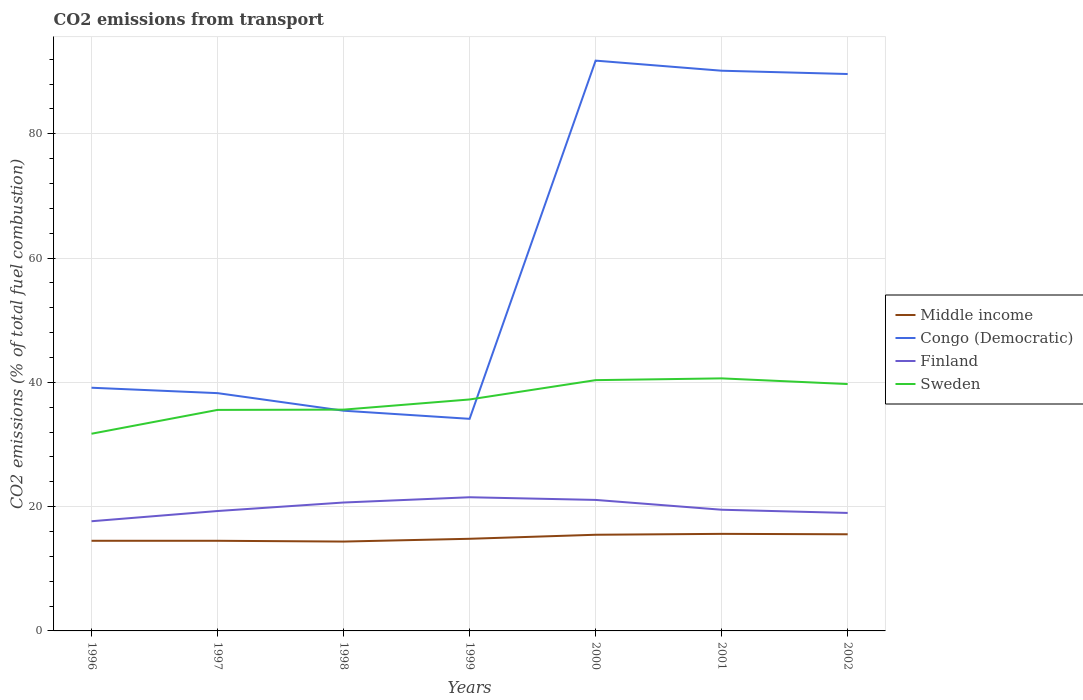Does the line corresponding to Sweden intersect with the line corresponding to Middle income?
Keep it short and to the point. No. Across all years, what is the maximum total CO2 emitted in Sweden?
Keep it short and to the point. 31.73. In which year was the total CO2 emitted in Middle income maximum?
Provide a short and direct response. 1998. What is the total total CO2 emitted in Middle income in the graph?
Ensure brevity in your answer.  -1.04. What is the difference between the highest and the second highest total CO2 emitted in Congo (Democratic)?
Your answer should be compact. 57.64. Is the total CO2 emitted in Finland strictly greater than the total CO2 emitted in Middle income over the years?
Keep it short and to the point. No. How many lines are there?
Your answer should be compact. 4. How many years are there in the graph?
Provide a short and direct response. 7. What is the difference between two consecutive major ticks on the Y-axis?
Offer a terse response. 20. Does the graph contain grids?
Ensure brevity in your answer.  Yes. Where does the legend appear in the graph?
Ensure brevity in your answer.  Center right. How are the legend labels stacked?
Your response must be concise. Vertical. What is the title of the graph?
Offer a terse response. CO2 emissions from transport. What is the label or title of the X-axis?
Give a very brief answer. Years. What is the label or title of the Y-axis?
Offer a very short reply. CO2 emissions (% of total fuel combustion). What is the CO2 emissions (% of total fuel combustion) of Middle income in 1996?
Make the answer very short. 14.51. What is the CO2 emissions (% of total fuel combustion) in Congo (Democratic) in 1996?
Ensure brevity in your answer.  39.13. What is the CO2 emissions (% of total fuel combustion) of Finland in 1996?
Provide a short and direct response. 17.65. What is the CO2 emissions (% of total fuel combustion) in Sweden in 1996?
Give a very brief answer. 31.73. What is the CO2 emissions (% of total fuel combustion) in Middle income in 1997?
Your answer should be very brief. 14.5. What is the CO2 emissions (% of total fuel combustion) in Congo (Democratic) in 1997?
Offer a very short reply. 38.26. What is the CO2 emissions (% of total fuel combustion) of Finland in 1997?
Offer a very short reply. 19.29. What is the CO2 emissions (% of total fuel combustion) of Sweden in 1997?
Your response must be concise. 35.56. What is the CO2 emissions (% of total fuel combustion) of Middle income in 1998?
Your response must be concise. 14.38. What is the CO2 emissions (% of total fuel combustion) in Congo (Democratic) in 1998?
Your answer should be very brief. 35.43. What is the CO2 emissions (% of total fuel combustion) in Finland in 1998?
Provide a succinct answer. 20.66. What is the CO2 emissions (% of total fuel combustion) of Sweden in 1998?
Make the answer very short. 35.61. What is the CO2 emissions (% of total fuel combustion) of Middle income in 1999?
Offer a terse response. 14.83. What is the CO2 emissions (% of total fuel combustion) in Congo (Democratic) in 1999?
Give a very brief answer. 34.13. What is the CO2 emissions (% of total fuel combustion) of Finland in 1999?
Your answer should be very brief. 21.51. What is the CO2 emissions (% of total fuel combustion) in Sweden in 1999?
Offer a very short reply. 37.24. What is the CO2 emissions (% of total fuel combustion) of Middle income in 2000?
Your response must be concise. 15.47. What is the CO2 emissions (% of total fuel combustion) of Congo (Democratic) in 2000?
Your answer should be very brief. 91.76. What is the CO2 emissions (% of total fuel combustion) in Finland in 2000?
Your answer should be compact. 21.08. What is the CO2 emissions (% of total fuel combustion) of Sweden in 2000?
Ensure brevity in your answer.  40.35. What is the CO2 emissions (% of total fuel combustion) of Middle income in 2001?
Offer a terse response. 15.62. What is the CO2 emissions (% of total fuel combustion) of Congo (Democratic) in 2001?
Your response must be concise. 90.14. What is the CO2 emissions (% of total fuel combustion) in Finland in 2001?
Your response must be concise. 19.5. What is the CO2 emissions (% of total fuel combustion) of Sweden in 2001?
Your response must be concise. 40.64. What is the CO2 emissions (% of total fuel combustion) of Middle income in 2002?
Your response must be concise. 15.55. What is the CO2 emissions (% of total fuel combustion) in Congo (Democratic) in 2002?
Give a very brief answer. 89.61. What is the CO2 emissions (% of total fuel combustion) in Finland in 2002?
Make the answer very short. 18.98. What is the CO2 emissions (% of total fuel combustion) in Sweden in 2002?
Provide a succinct answer. 39.72. Across all years, what is the maximum CO2 emissions (% of total fuel combustion) of Middle income?
Offer a very short reply. 15.62. Across all years, what is the maximum CO2 emissions (% of total fuel combustion) in Congo (Democratic)?
Make the answer very short. 91.76. Across all years, what is the maximum CO2 emissions (% of total fuel combustion) in Finland?
Make the answer very short. 21.51. Across all years, what is the maximum CO2 emissions (% of total fuel combustion) of Sweden?
Your answer should be very brief. 40.64. Across all years, what is the minimum CO2 emissions (% of total fuel combustion) of Middle income?
Your answer should be compact. 14.38. Across all years, what is the minimum CO2 emissions (% of total fuel combustion) of Congo (Democratic)?
Your response must be concise. 34.13. Across all years, what is the minimum CO2 emissions (% of total fuel combustion) of Finland?
Your response must be concise. 17.65. Across all years, what is the minimum CO2 emissions (% of total fuel combustion) in Sweden?
Provide a succinct answer. 31.73. What is the total CO2 emissions (% of total fuel combustion) of Middle income in the graph?
Make the answer very short. 104.85. What is the total CO2 emissions (% of total fuel combustion) of Congo (Democratic) in the graph?
Offer a very short reply. 418.47. What is the total CO2 emissions (% of total fuel combustion) in Finland in the graph?
Provide a succinct answer. 138.68. What is the total CO2 emissions (% of total fuel combustion) of Sweden in the graph?
Ensure brevity in your answer.  260.85. What is the difference between the CO2 emissions (% of total fuel combustion) of Middle income in 1996 and that in 1997?
Ensure brevity in your answer.  0. What is the difference between the CO2 emissions (% of total fuel combustion) of Congo (Democratic) in 1996 and that in 1997?
Ensure brevity in your answer.  0.87. What is the difference between the CO2 emissions (% of total fuel combustion) in Finland in 1996 and that in 1997?
Keep it short and to the point. -1.65. What is the difference between the CO2 emissions (% of total fuel combustion) in Sweden in 1996 and that in 1997?
Offer a very short reply. -3.83. What is the difference between the CO2 emissions (% of total fuel combustion) in Middle income in 1996 and that in 1998?
Your answer should be very brief. 0.13. What is the difference between the CO2 emissions (% of total fuel combustion) in Congo (Democratic) in 1996 and that in 1998?
Provide a succinct answer. 3.7. What is the difference between the CO2 emissions (% of total fuel combustion) of Finland in 1996 and that in 1998?
Keep it short and to the point. -3.01. What is the difference between the CO2 emissions (% of total fuel combustion) in Sweden in 1996 and that in 1998?
Provide a short and direct response. -3.88. What is the difference between the CO2 emissions (% of total fuel combustion) in Middle income in 1996 and that in 1999?
Ensure brevity in your answer.  -0.32. What is the difference between the CO2 emissions (% of total fuel combustion) in Congo (Democratic) in 1996 and that in 1999?
Your response must be concise. 5. What is the difference between the CO2 emissions (% of total fuel combustion) of Finland in 1996 and that in 1999?
Ensure brevity in your answer.  -3.86. What is the difference between the CO2 emissions (% of total fuel combustion) of Sweden in 1996 and that in 1999?
Your answer should be compact. -5.51. What is the difference between the CO2 emissions (% of total fuel combustion) in Middle income in 1996 and that in 2000?
Offer a terse response. -0.97. What is the difference between the CO2 emissions (% of total fuel combustion) in Congo (Democratic) in 1996 and that in 2000?
Provide a succinct answer. -52.63. What is the difference between the CO2 emissions (% of total fuel combustion) in Finland in 1996 and that in 2000?
Your answer should be very brief. -3.43. What is the difference between the CO2 emissions (% of total fuel combustion) of Sweden in 1996 and that in 2000?
Provide a short and direct response. -8.62. What is the difference between the CO2 emissions (% of total fuel combustion) in Middle income in 1996 and that in 2001?
Provide a succinct answer. -1.11. What is the difference between the CO2 emissions (% of total fuel combustion) in Congo (Democratic) in 1996 and that in 2001?
Keep it short and to the point. -51.01. What is the difference between the CO2 emissions (% of total fuel combustion) in Finland in 1996 and that in 2001?
Ensure brevity in your answer.  -1.85. What is the difference between the CO2 emissions (% of total fuel combustion) in Sweden in 1996 and that in 2001?
Provide a short and direct response. -8.91. What is the difference between the CO2 emissions (% of total fuel combustion) of Middle income in 1996 and that in 2002?
Offer a very short reply. -1.04. What is the difference between the CO2 emissions (% of total fuel combustion) of Congo (Democratic) in 1996 and that in 2002?
Offer a very short reply. -50.48. What is the difference between the CO2 emissions (% of total fuel combustion) of Finland in 1996 and that in 2002?
Offer a very short reply. -1.34. What is the difference between the CO2 emissions (% of total fuel combustion) in Sweden in 1996 and that in 2002?
Provide a succinct answer. -7.99. What is the difference between the CO2 emissions (% of total fuel combustion) of Middle income in 1997 and that in 1998?
Your answer should be very brief. 0.13. What is the difference between the CO2 emissions (% of total fuel combustion) of Congo (Democratic) in 1997 and that in 1998?
Keep it short and to the point. 2.83. What is the difference between the CO2 emissions (% of total fuel combustion) in Finland in 1997 and that in 1998?
Provide a short and direct response. -1.37. What is the difference between the CO2 emissions (% of total fuel combustion) of Sweden in 1997 and that in 1998?
Your response must be concise. -0.05. What is the difference between the CO2 emissions (% of total fuel combustion) in Middle income in 1997 and that in 1999?
Give a very brief answer. -0.32. What is the difference between the CO2 emissions (% of total fuel combustion) in Congo (Democratic) in 1997 and that in 1999?
Offer a terse response. 4.13. What is the difference between the CO2 emissions (% of total fuel combustion) in Finland in 1997 and that in 1999?
Ensure brevity in your answer.  -2.22. What is the difference between the CO2 emissions (% of total fuel combustion) of Sweden in 1997 and that in 1999?
Your response must be concise. -1.68. What is the difference between the CO2 emissions (% of total fuel combustion) in Middle income in 1997 and that in 2000?
Ensure brevity in your answer.  -0.97. What is the difference between the CO2 emissions (% of total fuel combustion) of Congo (Democratic) in 1997 and that in 2000?
Offer a terse response. -53.5. What is the difference between the CO2 emissions (% of total fuel combustion) in Finland in 1997 and that in 2000?
Your answer should be compact. -1.79. What is the difference between the CO2 emissions (% of total fuel combustion) in Sweden in 1997 and that in 2000?
Your answer should be very brief. -4.79. What is the difference between the CO2 emissions (% of total fuel combustion) in Middle income in 1997 and that in 2001?
Your answer should be very brief. -1.11. What is the difference between the CO2 emissions (% of total fuel combustion) in Congo (Democratic) in 1997 and that in 2001?
Offer a terse response. -51.88. What is the difference between the CO2 emissions (% of total fuel combustion) in Finland in 1997 and that in 2001?
Keep it short and to the point. -0.21. What is the difference between the CO2 emissions (% of total fuel combustion) in Sweden in 1997 and that in 2001?
Make the answer very short. -5.07. What is the difference between the CO2 emissions (% of total fuel combustion) in Middle income in 1997 and that in 2002?
Offer a terse response. -1.04. What is the difference between the CO2 emissions (% of total fuel combustion) in Congo (Democratic) in 1997 and that in 2002?
Offer a terse response. -51.35. What is the difference between the CO2 emissions (% of total fuel combustion) of Finland in 1997 and that in 2002?
Your answer should be compact. 0.31. What is the difference between the CO2 emissions (% of total fuel combustion) of Sweden in 1997 and that in 2002?
Your answer should be compact. -4.16. What is the difference between the CO2 emissions (% of total fuel combustion) in Middle income in 1998 and that in 1999?
Your answer should be compact. -0.45. What is the difference between the CO2 emissions (% of total fuel combustion) of Congo (Democratic) in 1998 and that in 1999?
Offer a very short reply. 1.31. What is the difference between the CO2 emissions (% of total fuel combustion) of Finland in 1998 and that in 1999?
Keep it short and to the point. -0.85. What is the difference between the CO2 emissions (% of total fuel combustion) of Sweden in 1998 and that in 1999?
Provide a succinct answer. -1.64. What is the difference between the CO2 emissions (% of total fuel combustion) in Middle income in 1998 and that in 2000?
Provide a succinct answer. -1.1. What is the difference between the CO2 emissions (% of total fuel combustion) in Congo (Democratic) in 1998 and that in 2000?
Provide a succinct answer. -56.33. What is the difference between the CO2 emissions (% of total fuel combustion) of Finland in 1998 and that in 2000?
Offer a very short reply. -0.42. What is the difference between the CO2 emissions (% of total fuel combustion) of Sweden in 1998 and that in 2000?
Provide a short and direct response. -4.75. What is the difference between the CO2 emissions (% of total fuel combustion) in Middle income in 1998 and that in 2001?
Provide a succinct answer. -1.24. What is the difference between the CO2 emissions (% of total fuel combustion) of Congo (Democratic) in 1998 and that in 2001?
Provide a short and direct response. -54.71. What is the difference between the CO2 emissions (% of total fuel combustion) in Finland in 1998 and that in 2001?
Provide a succinct answer. 1.16. What is the difference between the CO2 emissions (% of total fuel combustion) of Sweden in 1998 and that in 2001?
Offer a very short reply. -5.03. What is the difference between the CO2 emissions (% of total fuel combustion) in Middle income in 1998 and that in 2002?
Give a very brief answer. -1.17. What is the difference between the CO2 emissions (% of total fuel combustion) of Congo (Democratic) in 1998 and that in 2002?
Your answer should be compact. -54.18. What is the difference between the CO2 emissions (% of total fuel combustion) in Finland in 1998 and that in 2002?
Give a very brief answer. 1.68. What is the difference between the CO2 emissions (% of total fuel combustion) of Sweden in 1998 and that in 2002?
Offer a very short reply. -4.12. What is the difference between the CO2 emissions (% of total fuel combustion) in Middle income in 1999 and that in 2000?
Your answer should be compact. -0.65. What is the difference between the CO2 emissions (% of total fuel combustion) of Congo (Democratic) in 1999 and that in 2000?
Your answer should be compact. -57.64. What is the difference between the CO2 emissions (% of total fuel combustion) in Finland in 1999 and that in 2000?
Provide a succinct answer. 0.43. What is the difference between the CO2 emissions (% of total fuel combustion) in Sweden in 1999 and that in 2000?
Keep it short and to the point. -3.11. What is the difference between the CO2 emissions (% of total fuel combustion) of Middle income in 1999 and that in 2001?
Your answer should be compact. -0.79. What is the difference between the CO2 emissions (% of total fuel combustion) of Congo (Democratic) in 1999 and that in 2001?
Your answer should be very brief. -56.01. What is the difference between the CO2 emissions (% of total fuel combustion) of Finland in 1999 and that in 2001?
Your answer should be very brief. 2.01. What is the difference between the CO2 emissions (% of total fuel combustion) of Sweden in 1999 and that in 2001?
Give a very brief answer. -3.39. What is the difference between the CO2 emissions (% of total fuel combustion) in Middle income in 1999 and that in 2002?
Provide a short and direct response. -0.72. What is the difference between the CO2 emissions (% of total fuel combustion) of Congo (Democratic) in 1999 and that in 2002?
Your answer should be compact. -55.48. What is the difference between the CO2 emissions (% of total fuel combustion) in Finland in 1999 and that in 2002?
Provide a short and direct response. 2.52. What is the difference between the CO2 emissions (% of total fuel combustion) in Sweden in 1999 and that in 2002?
Your response must be concise. -2.48. What is the difference between the CO2 emissions (% of total fuel combustion) of Middle income in 2000 and that in 2001?
Your answer should be compact. -0.14. What is the difference between the CO2 emissions (% of total fuel combustion) of Congo (Democratic) in 2000 and that in 2001?
Your answer should be very brief. 1.62. What is the difference between the CO2 emissions (% of total fuel combustion) in Finland in 2000 and that in 2001?
Make the answer very short. 1.58. What is the difference between the CO2 emissions (% of total fuel combustion) in Sweden in 2000 and that in 2001?
Your response must be concise. -0.28. What is the difference between the CO2 emissions (% of total fuel combustion) of Middle income in 2000 and that in 2002?
Offer a terse response. -0.07. What is the difference between the CO2 emissions (% of total fuel combustion) of Congo (Democratic) in 2000 and that in 2002?
Make the answer very short. 2.15. What is the difference between the CO2 emissions (% of total fuel combustion) in Finland in 2000 and that in 2002?
Provide a succinct answer. 2.1. What is the difference between the CO2 emissions (% of total fuel combustion) in Sweden in 2000 and that in 2002?
Offer a very short reply. 0.63. What is the difference between the CO2 emissions (% of total fuel combustion) of Middle income in 2001 and that in 2002?
Your answer should be very brief. 0.07. What is the difference between the CO2 emissions (% of total fuel combustion) of Congo (Democratic) in 2001 and that in 2002?
Make the answer very short. 0.53. What is the difference between the CO2 emissions (% of total fuel combustion) of Finland in 2001 and that in 2002?
Your response must be concise. 0.52. What is the difference between the CO2 emissions (% of total fuel combustion) of Sweden in 2001 and that in 2002?
Make the answer very short. 0.91. What is the difference between the CO2 emissions (% of total fuel combustion) in Middle income in 1996 and the CO2 emissions (% of total fuel combustion) in Congo (Democratic) in 1997?
Provide a short and direct response. -23.76. What is the difference between the CO2 emissions (% of total fuel combustion) of Middle income in 1996 and the CO2 emissions (% of total fuel combustion) of Finland in 1997?
Offer a terse response. -4.79. What is the difference between the CO2 emissions (% of total fuel combustion) in Middle income in 1996 and the CO2 emissions (% of total fuel combustion) in Sweden in 1997?
Your response must be concise. -21.06. What is the difference between the CO2 emissions (% of total fuel combustion) in Congo (Democratic) in 1996 and the CO2 emissions (% of total fuel combustion) in Finland in 1997?
Offer a very short reply. 19.84. What is the difference between the CO2 emissions (% of total fuel combustion) in Congo (Democratic) in 1996 and the CO2 emissions (% of total fuel combustion) in Sweden in 1997?
Provide a succinct answer. 3.57. What is the difference between the CO2 emissions (% of total fuel combustion) in Finland in 1996 and the CO2 emissions (% of total fuel combustion) in Sweden in 1997?
Keep it short and to the point. -17.91. What is the difference between the CO2 emissions (% of total fuel combustion) of Middle income in 1996 and the CO2 emissions (% of total fuel combustion) of Congo (Democratic) in 1998?
Keep it short and to the point. -20.93. What is the difference between the CO2 emissions (% of total fuel combustion) in Middle income in 1996 and the CO2 emissions (% of total fuel combustion) in Finland in 1998?
Offer a terse response. -6.16. What is the difference between the CO2 emissions (% of total fuel combustion) in Middle income in 1996 and the CO2 emissions (% of total fuel combustion) in Sweden in 1998?
Your answer should be compact. -21.1. What is the difference between the CO2 emissions (% of total fuel combustion) in Congo (Democratic) in 1996 and the CO2 emissions (% of total fuel combustion) in Finland in 1998?
Make the answer very short. 18.47. What is the difference between the CO2 emissions (% of total fuel combustion) of Congo (Democratic) in 1996 and the CO2 emissions (% of total fuel combustion) of Sweden in 1998?
Your answer should be compact. 3.52. What is the difference between the CO2 emissions (% of total fuel combustion) in Finland in 1996 and the CO2 emissions (% of total fuel combustion) in Sweden in 1998?
Your answer should be compact. -17.96. What is the difference between the CO2 emissions (% of total fuel combustion) of Middle income in 1996 and the CO2 emissions (% of total fuel combustion) of Congo (Democratic) in 1999?
Your response must be concise. -19.62. What is the difference between the CO2 emissions (% of total fuel combustion) in Middle income in 1996 and the CO2 emissions (% of total fuel combustion) in Finland in 1999?
Provide a succinct answer. -7. What is the difference between the CO2 emissions (% of total fuel combustion) in Middle income in 1996 and the CO2 emissions (% of total fuel combustion) in Sweden in 1999?
Your response must be concise. -22.74. What is the difference between the CO2 emissions (% of total fuel combustion) of Congo (Democratic) in 1996 and the CO2 emissions (% of total fuel combustion) of Finland in 1999?
Your answer should be compact. 17.62. What is the difference between the CO2 emissions (% of total fuel combustion) of Congo (Democratic) in 1996 and the CO2 emissions (% of total fuel combustion) of Sweden in 1999?
Your response must be concise. 1.89. What is the difference between the CO2 emissions (% of total fuel combustion) in Finland in 1996 and the CO2 emissions (% of total fuel combustion) in Sweden in 1999?
Ensure brevity in your answer.  -19.59. What is the difference between the CO2 emissions (% of total fuel combustion) of Middle income in 1996 and the CO2 emissions (% of total fuel combustion) of Congo (Democratic) in 2000?
Your answer should be compact. -77.26. What is the difference between the CO2 emissions (% of total fuel combustion) of Middle income in 1996 and the CO2 emissions (% of total fuel combustion) of Finland in 2000?
Your response must be concise. -6.57. What is the difference between the CO2 emissions (% of total fuel combustion) in Middle income in 1996 and the CO2 emissions (% of total fuel combustion) in Sweden in 2000?
Your answer should be compact. -25.85. What is the difference between the CO2 emissions (% of total fuel combustion) of Congo (Democratic) in 1996 and the CO2 emissions (% of total fuel combustion) of Finland in 2000?
Provide a short and direct response. 18.05. What is the difference between the CO2 emissions (% of total fuel combustion) in Congo (Democratic) in 1996 and the CO2 emissions (% of total fuel combustion) in Sweden in 2000?
Give a very brief answer. -1.22. What is the difference between the CO2 emissions (% of total fuel combustion) in Finland in 1996 and the CO2 emissions (% of total fuel combustion) in Sweden in 2000?
Ensure brevity in your answer.  -22.7. What is the difference between the CO2 emissions (% of total fuel combustion) in Middle income in 1996 and the CO2 emissions (% of total fuel combustion) in Congo (Democratic) in 2001?
Ensure brevity in your answer.  -75.64. What is the difference between the CO2 emissions (% of total fuel combustion) of Middle income in 1996 and the CO2 emissions (% of total fuel combustion) of Finland in 2001?
Ensure brevity in your answer.  -4.99. What is the difference between the CO2 emissions (% of total fuel combustion) in Middle income in 1996 and the CO2 emissions (% of total fuel combustion) in Sweden in 2001?
Your response must be concise. -26.13. What is the difference between the CO2 emissions (% of total fuel combustion) of Congo (Democratic) in 1996 and the CO2 emissions (% of total fuel combustion) of Finland in 2001?
Provide a succinct answer. 19.63. What is the difference between the CO2 emissions (% of total fuel combustion) of Congo (Democratic) in 1996 and the CO2 emissions (% of total fuel combustion) of Sweden in 2001?
Your answer should be very brief. -1.51. What is the difference between the CO2 emissions (% of total fuel combustion) in Finland in 1996 and the CO2 emissions (% of total fuel combustion) in Sweden in 2001?
Your response must be concise. -22.99. What is the difference between the CO2 emissions (% of total fuel combustion) of Middle income in 1996 and the CO2 emissions (% of total fuel combustion) of Congo (Democratic) in 2002?
Your answer should be compact. -75.11. What is the difference between the CO2 emissions (% of total fuel combustion) in Middle income in 1996 and the CO2 emissions (% of total fuel combustion) in Finland in 2002?
Ensure brevity in your answer.  -4.48. What is the difference between the CO2 emissions (% of total fuel combustion) in Middle income in 1996 and the CO2 emissions (% of total fuel combustion) in Sweden in 2002?
Give a very brief answer. -25.22. What is the difference between the CO2 emissions (% of total fuel combustion) of Congo (Democratic) in 1996 and the CO2 emissions (% of total fuel combustion) of Finland in 2002?
Your answer should be very brief. 20.15. What is the difference between the CO2 emissions (% of total fuel combustion) of Congo (Democratic) in 1996 and the CO2 emissions (% of total fuel combustion) of Sweden in 2002?
Your answer should be compact. -0.59. What is the difference between the CO2 emissions (% of total fuel combustion) in Finland in 1996 and the CO2 emissions (% of total fuel combustion) in Sweden in 2002?
Give a very brief answer. -22.07. What is the difference between the CO2 emissions (% of total fuel combustion) in Middle income in 1997 and the CO2 emissions (% of total fuel combustion) in Congo (Democratic) in 1998?
Make the answer very short. -20.93. What is the difference between the CO2 emissions (% of total fuel combustion) of Middle income in 1997 and the CO2 emissions (% of total fuel combustion) of Finland in 1998?
Keep it short and to the point. -6.16. What is the difference between the CO2 emissions (% of total fuel combustion) in Middle income in 1997 and the CO2 emissions (% of total fuel combustion) in Sweden in 1998?
Keep it short and to the point. -21.1. What is the difference between the CO2 emissions (% of total fuel combustion) of Congo (Democratic) in 1997 and the CO2 emissions (% of total fuel combustion) of Finland in 1998?
Offer a terse response. 17.6. What is the difference between the CO2 emissions (% of total fuel combustion) of Congo (Democratic) in 1997 and the CO2 emissions (% of total fuel combustion) of Sweden in 1998?
Ensure brevity in your answer.  2.65. What is the difference between the CO2 emissions (% of total fuel combustion) of Finland in 1997 and the CO2 emissions (% of total fuel combustion) of Sweden in 1998?
Offer a very short reply. -16.31. What is the difference between the CO2 emissions (% of total fuel combustion) in Middle income in 1997 and the CO2 emissions (% of total fuel combustion) in Congo (Democratic) in 1999?
Provide a succinct answer. -19.62. What is the difference between the CO2 emissions (% of total fuel combustion) of Middle income in 1997 and the CO2 emissions (% of total fuel combustion) of Finland in 1999?
Your answer should be very brief. -7. What is the difference between the CO2 emissions (% of total fuel combustion) in Middle income in 1997 and the CO2 emissions (% of total fuel combustion) in Sweden in 1999?
Your answer should be very brief. -22.74. What is the difference between the CO2 emissions (% of total fuel combustion) of Congo (Democratic) in 1997 and the CO2 emissions (% of total fuel combustion) of Finland in 1999?
Make the answer very short. 16.75. What is the difference between the CO2 emissions (% of total fuel combustion) in Congo (Democratic) in 1997 and the CO2 emissions (% of total fuel combustion) in Sweden in 1999?
Make the answer very short. 1.02. What is the difference between the CO2 emissions (% of total fuel combustion) of Finland in 1997 and the CO2 emissions (% of total fuel combustion) of Sweden in 1999?
Your answer should be very brief. -17.95. What is the difference between the CO2 emissions (% of total fuel combustion) of Middle income in 1997 and the CO2 emissions (% of total fuel combustion) of Congo (Democratic) in 2000?
Your answer should be very brief. -77.26. What is the difference between the CO2 emissions (% of total fuel combustion) of Middle income in 1997 and the CO2 emissions (% of total fuel combustion) of Finland in 2000?
Your answer should be very brief. -6.57. What is the difference between the CO2 emissions (% of total fuel combustion) of Middle income in 1997 and the CO2 emissions (% of total fuel combustion) of Sweden in 2000?
Keep it short and to the point. -25.85. What is the difference between the CO2 emissions (% of total fuel combustion) of Congo (Democratic) in 1997 and the CO2 emissions (% of total fuel combustion) of Finland in 2000?
Make the answer very short. 17.18. What is the difference between the CO2 emissions (% of total fuel combustion) in Congo (Democratic) in 1997 and the CO2 emissions (% of total fuel combustion) in Sweden in 2000?
Offer a terse response. -2.09. What is the difference between the CO2 emissions (% of total fuel combustion) of Finland in 1997 and the CO2 emissions (% of total fuel combustion) of Sweden in 2000?
Your response must be concise. -21.06. What is the difference between the CO2 emissions (% of total fuel combustion) of Middle income in 1997 and the CO2 emissions (% of total fuel combustion) of Congo (Democratic) in 2001?
Provide a short and direct response. -75.64. What is the difference between the CO2 emissions (% of total fuel combustion) in Middle income in 1997 and the CO2 emissions (% of total fuel combustion) in Finland in 2001?
Provide a short and direct response. -5. What is the difference between the CO2 emissions (% of total fuel combustion) of Middle income in 1997 and the CO2 emissions (% of total fuel combustion) of Sweden in 2001?
Offer a very short reply. -26.13. What is the difference between the CO2 emissions (% of total fuel combustion) of Congo (Democratic) in 1997 and the CO2 emissions (% of total fuel combustion) of Finland in 2001?
Your answer should be very brief. 18.76. What is the difference between the CO2 emissions (% of total fuel combustion) in Congo (Democratic) in 1997 and the CO2 emissions (% of total fuel combustion) in Sweden in 2001?
Make the answer very short. -2.37. What is the difference between the CO2 emissions (% of total fuel combustion) in Finland in 1997 and the CO2 emissions (% of total fuel combustion) in Sweden in 2001?
Provide a succinct answer. -21.34. What is the difference between the CO2 emissions (% of total fuel combustion) in Middle income in 1997 and the CO2 emissions (% of total fuel combustion) in Congo (Democratic) in 2002?
Your answer should be compact. -75.11. What is the difference between the CO2 emissions (% of total fuel combustion) in Middle income in 1997 and the CO2 emissions (% of total fuel combustion) in Finland in 2002?
Offer a very short reply. -4.48. What is the difference between the CO2 emissions (% of total fuel combustion) of Middle income in 1997 and the CO2 emissions (% of total fuel combustion) of Sweden in 2002?
Ensure brevity in your answer.  -25.22. What is the difference between the CO2 emissions (% of total fuel combustion) in Congo (Democratic) in 1997 and the CO2 emissions (% of total fuel combustion) in Finland in 2002?
Provide a succinct answer. 19.28. What is the difference between the CO2 emissions (% of total fuel combustion) of Congo (Democratic) in 1997 and the CO2 emissions (% of total fuel combustion) of Sweden in 2002?
Ensure brevity in your answer.  -1.46. What is the difference between the CO2 emissions (% of total fuel combustion) of Finland in 1997 and the CO2 emissions (% of total fuel combustion) of Sweden in 2002?
Ensure brevity in your answer.  -20.43. What is the difference between the CO2 emissions (% of total fuel combustion) in Middle income in 1998 and the CO2 emissions (% of total fuel combustion) in Congo (Democratic) in 1999?
Ensure brevity in your answer.  -19.75. What is the difference between the CO2 emissions (% of total fuel combustion) in Middle income in 1998 and the CO2 emissions (% of total fuel combustion) in Finland in 1999?
Give a very brief answer. -7.13. What is the difference between the CO2 emissions (% of total fuel combustion) in Middle income in 1998 and the CO2 emissions (% of total fuel combustion) in Sweden in 1999?
Your response must be concise. -22.86. What is the difference between the CO2 emissions (% of total fuel combustion) of Congo (Democratic) in 1998 and the CO2 emissions (% of total fuel combustion) of Finland in 1999?
Give a very brief answer. 13.92. What is the difference between the CO2 emissions (% of total fuel combustion) in Congo (Democratic) in 1998 and the CO2 emissions (% of total fuel combustion) in Sweden in 1999?
Provide a short and direct response. -1.81. What is the difference between the CO2 emissions (% of total fuel combustion) of Finland in 1998 and the CO2 emissions (% of total fuel combustion) of Sweden in 1999?
Offer a very short reply. -16.58. What is the difference between the CO2 emissions (% of total fuel combustion) in Middle income in 1998 and the CO2 emissions (% of total fuel combustion) in Congo (Democratic) in 2000?
Your response must be concise. -77.39. What is the difference between the CO2 emissions (% of total fuel combustion) of Middle income in 1998 and the CO2 emissions (% of total fuel combustion) of Finland in 2000?
Provide a succinct answer. -6.7. What is the difference between the CO2 emissions (% of total fuel combustion) in Middle income in 1998 and the CO2 emissions (% of total fuel combustion) in Sweden in 2000?
Your response must be concise. -25.98. What is the difference between the CO2 emissions (% of total fuel combustion) in Congo (Democratic) in 1998 and the CO2 emissions (% of total fuel combustion) in Finland in 2000?
Make the answer very short. 14.35. What is the difference between the CO2 emissions (% of total fuel combustion) of Congo (Democratic) in 1998 and the CO2 emissions (% of total fuel combustion) of Sweden in 2000?
Give a very brief answer. -4.92. What is the difference between the CO2 emissions (% of total fuel combustion) of Finland in 1998 and the CO2 emissions (% of total fuel combustion) of Sweden in 2000?
Make the answer very short. -19.69. What is the difference between the CO2 emissions (% of total fuel combustion) in Middle income in 1998 and the CO2 emissions (% of total fuel combustion) in Congo (Democratic) in 2001?
Your answer should be compact. -75.76. What is the difference between the CO2 emissions (% of total fuel combustion) of Middle income in 1998 and the CO2 emissions (% of total fuel combustion) of Finland in 2001?
Provide a short and direct response. -5.12. What is the difference between the CO2 emissions (% of total fuel combustion) of Middle income in 1998 and the CO2 emissions (% of total fuel combustion) of Sweden in 2001?
Ensure brevity in your answer.  -26.26. What is the difference between the CO2 emissions (% of total fuel combustion) in Congo (Democratic) in 1998 and the CO2 emissions (% of total fuel combustion) in Finland in 2001?
Make the answer very short. 15.93. What is the difference between the CO2 emissions (% of total fuel combustion) in Congo (Democratic) in 1998 and the CO2 emissions (% of total fuel combustion) in Sweden in 2001?
Your answer should be very brief. -5.2. What is the difference between the CO2 emissions (% of total fuel combustion) in Finland in 1998 and the CO2 emissions (% of total fuel combustion) in Sweden in 2001?
Your answer should be compact. -19.97. What is the difference between the CO2 emissions (% of total fuel combustion) of Middle income in 1998 and the CO2 emissions (% of total fuel combustion) of Congo (Democratic) in 2002?
Offer a terse response. -75.23. What is the difference between the CO2 emissions (% of total fuel combustion) of Middle income in 1998 and the CO2 emissions (% of total fuel combustion) of Finland in 2002?
Ensure brevity in your answer.  -4.61. What is the difference between the CO2 emissions (% of total fuel combustion) of Middle income in 1998 and the CO2 emissions (% of total fuel combustion) of Sweden in 2002?
Offer a very short reply. -25.34. What is the difference between the CO2 emissions (% of total fuel combustion) in Congo (Democratic) in 1998 and the CO2 emissions (% of total fuel combustion) in Finland in 2002?
Ensure brevity in your answer.  16.45. What is the difference between the CO2 emissions (% of total fuel combustion) in Congo (Democratic) in 1998 and the CO2 emissions (% of total fuel combustion) in Sweden in 2002?
Offer a terse response. -4.29. What is the difference between the CO2 emissions (% of total fuel combustion) in Finland in 1998 and the CO2 emissions (% of total fuel combustion) in Sweden in 2002?
Give a very brief answer. -19.06. What is the difference between the CO2 emissions (% of total fuel combustion) in Middle income in 1999 and the CO2 emissions (% of total fuel combustion) in Congo (Democratic) in 2000?
Your answer should be very brief. -76.94. What is the difference between the CO2 emissions (% of total fuel combustion) in Middle income in 1999 and the CO2 emissions (% of total fuel combustion) in Finland in 2000?
Offer a terse response. -6.25. What is the difference between the CO2 emissions (% of total fuel combustion) in Middle income in 1999 and the CO2 emissions (% of total fuel combustion) in Sweden in 2000?
Offer a terse response. -25.53. What is the difference between the CO2 emissions (% of total fuel combustion) in Congo (Democratic) in 1999 and the CO2 emissions (% of total fuel combustion) in Finland in 2000?
Give a very brief answer. 13.05. What is the difference between the CO2 emissions (% of total fuel combustion) in Congo (Democratic) in 1999 and the CO2 emissions (% of total fuel combustion) in Sweden in 2000?
Your answer should be very brief. -6.23. What is the difference between the CO2 emissions (% of total fuel combustion) of Finland in 1999 and the CO2 emissions (% of total fuel combustion) of Sweden in 2000?
Keep it short and to the point. -18.84. What is the difference between the CO2 emissions (% of total fuel combustion) in Middle income in 1999 and the CO2 emissions (% of total fuel combustion) in Congo (Democratic) in 2001?
Offer a terse response. -75.31. What is the difference between the CO2 emissions (% of total fuel combustion) of Middle income in 1999 and the CO2 emissions (% of total fuel combustion) of Finland in 2001?
Make the answer very short. -4.67. What is the difference between the CO2 emissions (% of total fuel combustion) of Middle income in 1999 and the CO2 emissions (% of total fuel combustion) of Sweden in 2001?
Your response must be concise. -25.81. What is the difference between the CO2 emissions (% of total fuel combustion) in Congo (Democratic) in 1999 and the CO2 emissions (% of total fuel combustion) in Finland in 2001?
Your answer should be compact. 14.63. What is the difference between the CO2 emissions (% of total fuel combustion) in Congo (Democratic) in 1999 and the CO2 emissions (% of total fuel combustion) in Sweden in 2001?
Your response must be concise. -6.51. What is the difference between the CO2 emissions (% of total fuel combustion) in Finland in 1999 and the CO2 emissions (% of total fuel combustion) in Sweden in 2001?
Make the answer very short. -19.13. What is the difference between the CO2 emissions (% of total fuel combustion) in Middle income in 1999 and the CO2 emissions (% of total fuel combustion) in Congo (Democratic) in 2002?
Your answer should be very brief. -74.78. What is the difference between the CO2 emissions (% of total fuel combustion) of Middle income in 1999 and the CO2 emissions (% of total fuel combustion) of Finland in 2002?
Offer a terse response. -4.16. What is the difference between the CO2 emissions (% of total fuel combustion) in Middle income in 1999 and the CO2 emissions (% of total fuel combustion) in Sweden in 2002?
Keep it short and to the point. -24.9. What is the difference between the CO2 emissions (% of total fuel combustion) in Congo (Democratic) in 1999 and the CO2 emissions (% of total fuel combustion) in Finland in 2002?
Give a very brief answer. 15.14. What is the difference between the CO2 emissions (% of total fuel combustion) of Congo (Democratic) in 1999 and the CO2 emissions (% of total fuel combustion) of Sweden in 2002?
Ensure brevity in your answer.  -5.6. What is the difference between the CO2 emissions (% of total fuel combustion) of Finland in 1999 and the CO2 emissions (% of total fuel combustion) of Sweden in 2002?
Offer a very short reply. -18.21. What is the difference between the CO2 emissions (% of total fuel combustion) of Middle income in 2000 and the CO2 emissions (% of total fuel combustion) of Congo (Democratic) in 2001?
Make the answer very short. -74.67. What is the difference between the CO2 emissions (% of total fuel combustion) in Middle income in 2000 and the CO2 emissions (% of total fuel combustion) in Finland in 2001?
Your response must be concise. -4.03. What is the difference between the CO2 emissions (% of total fuel combustion) of Middle income in 2000 and the CO2 emissions (% of total fuel combustion) of Sweden in 2001?
Provide a succinct answer. -25.16. What is the difference between the CO2 emissions (% of total fuel combustion) in Congo (Democratic) in 2000 and the CO2 emissions (% of total fuel combustion) in Finland in 2001?
Keep it short and to the point. 72.26. What is the difference between the CO2 emissions (% of total fuel combustion) in Congo (Democratic) in 2000 and the CO2 emissions (% of total fuel combustion) in Sweden in 2001?
Keep it short and to the point. 51.13. What is the difference between the CO2 emissions (% of total fuel combustion) in Finland in 2000 and the CO2 emissions (% of total fuel combustion) in Sweden in 2001?
Your answer should be compact. -19.56. What is the difference between the CO2 emissions (% of total fuel combustion) of Middle income in 2000 and the CO2 emissions (% of total fuel combustion) of Congo (Democratic) in 2002?
Keep it short and to the point. -74.14. What is the difference between the CO2 emissions (% of total fuel combustion) in Middle income in 2000 and the CO2 emissions (% of total fuel combustion) in Finland in 2002?
Your response must be concise. -3.51. What is the difference between the CO2 emissions (% of total fuel combustion) in Middle income in 2000 and the CO2 emissions (% of total fuel combustion) in Sweden in 2002?
Offer a very short reply. -24.25. What is the difference between the CO2 emissions (% of total fuel combustion) in Congo (Democratic) in 2000 and the CO2 emissions (% of total fuel combustion) in Finland in 2002?
Offer a terse response. 72.78. What is the difference between the CO2 emissions (% of total fuel combustion) in Congo (Democratic) in 2000 and the CO2 emissions (% of total fuel combustion) in Sweden in 2002?
Provide a succinct answer. 52.04. What is the difference between the CO2 emissions (% of total fuel combustion) in Finland in 2000 and the CO2 emissions (% of total fuel combustion) in Sweden in 2002?
Make the answer very short. -18.64. What is the difference between the CO2 emissions (% of total fuel combustion) in Middle income in 2001 and the CO2 emissions (% of total fuel combustion) in Congo (Democratic) in 2002?
Provide a succinct answer. -73.99. What is the difference between the CO2 emissions (% of total fuel combustion) of Middle income in 2001 and the CO2 emissions (% of total fuel combustion) of Finland in 2002?
Ensure brevity in your answer.  -3.37. What is the difference between the CO2 emissions (% of total fuel combustion) of Middle income in 2001 and the CO2 emissions (% of total fuel combustion) of Sweden in 2002?
Give a very brief answer. -24.11. What is the difference between the CO2 emissions (% of total fuel combustion) of Congo (Democratic) in 2001 and the CO2 emissions (% of total fuel combustion) of Finland in 2002?
Provide a succinct answer. 71.16. What is the difference between the CO2 emissions (% of total fuel combustion) of Congo (Democratic) in 2001 and the CO2 emissions (% of total fuel combustion) of Sweden in 2002?
Your answer should be very brief. 50.42. What is the difference between the CO2 emissions (% of total fuel combustion) of Finland in 2001 and the CO2 emissions (% of total fuel combustion) of Sweden in 2002?
Your answer should be compact. -20.22. What is the average CO2 emissions (% of total fuel combustion) of Middle income per year?
Offer a very short reply. 14.98. What is the average CO2 emissions (% of total fuel combustion) of Congo (Democratic) per year?
Make the answer very short. 59.78. What is the average CO2 emissions (% of total fuel combustion) of Finland per year?
Give a very brief answer. 19.81. What is the average CO2 emissions (% of total fuel combustion) of Sweden per year?
Your response must be concise. 37.26. In the year 1996, what is the difference between the CO2 emissions (% of total fuel combustion) in Middle income and CO2 emissions (% of total fuel combustion) in Congo (Democratic)?
Provide a succinct answer. -24.63. In the year 1996, what is the difference between the CO2 emissions (% of total fuel combustion) of Middle income and CO2 emissions (% of total fuel combustion) of Finland?
Your answer should be compact. -3.14. In the year 1996, what is the difference between the CO2 emissions (% of total fuel combustion) in Middle income and CO2 emissions (% of total fuel combustion) in Sweden?
Ensure brevity in your answer.  -17.22. In the year 1996, what is the difference between the CO2 emissions (% of total fuel combustion) of Congo (Democratic) and CO2 emissions (% of total fuel combustion) of Finland?
Your answer should be very brief. 21.48. In the year 1996, what is the difference between the CO2 emissions (% of total fuel combustion) of Congo (Democratic) and CO2 emissions (% of total fuel combustion) of Sweden?
Provide a succinct answer. 7.4. In the year 1996, what is the difference between the CO2 emissions (% of total fuel combustion) of Finland and CO2 emissions (% of total fuel combustion) of Sweden?
Make the answer very short. -14.08. In the year 1997, what is the difference between the CO2 emissions (% of total fuel combustion) of Middle income and CO2 emissions (% of total fuel combustion) of Congo (Democratic)?
Your answer should be very brief. -23.76. In the year 1997, what is the difference between the CO2 emissions (% of total fuel combustion) in Middle income and CO2 emissions (% of total fuel combustion) in Finland?
Your response must be concise. -4.79. In the year 1997, what is the difference between the CO2 emissions (% of total fuel combustion) in Middle income and CO2 emissions (% of total fuel combustion) in Sweden?
Provide a succinct answer. -21.06. In the year 1997, what is the difference between the CO2 emissions (% of total fuel combustion) of Congo (Democratic) and CO2 emissions (% of total fuel combustion) of Finland?
Your response must be concise. 18.97. In the year 1997, what is the difference between the CO2 emissions (% of total fuel combustion) in Congo (Democratic) and CO2 emissions (% of total fuel combustion) in Sweden?
Ensure brevity in your answer.  2.7. In the year 1997, what is the difference between the CO2 emissions (% of total fuel combustion) of Finland and CO2 emissions (% of total fuel combustion) of Sweden?
Offer a terse response. -16.27. In the year 1998, what is the difference between the CO2 emissions (% of total fuel combustion) of Middle income and CO2 emissions (% of total fuel combustion) of Congo (Democratic)?
Your answer should be very brief. -21.06. In the year 1998, what is the difference between the CO2 emissions (% of total fuel combustion) of Middle income and CO2 emissions (% of total fuel combustion) of Finland?
Keep it short and to the point. -6.28. In the year 1998, what is the difference between the CO2 emissions (% of total fuel combustion) in Middle income and CO2 emissions (% of total fuel combustion) in Sweden?
Give a very brief answer. -21.23. In the year 1998, what is the difference between the CO2 emissions (% of total fuel combustion) in Congo (Democratic) and CO2 emissions (% of total fuel combustion) in Finland?
Give a very brief answer. 14.77. In the year 1998, what is the difference between the CO2 emissions (% of total fuel combustion) of Congo (Democratic) and CO2 emissions (% of total fuel combustion) of Sweden?
Offer a very short reply. -0.17. In the year 1998, what is the difference between the CO2 emissions (% of total fuel combustion) of Finland and CO2 emissions (% of total fuel combustion) of Sweden?
Your response must be concise. -14.94. In the year 1999, what is the difference between the CO2 emissions (% of total fuel combustion) in Middle income and CO2 emissions (% of total fuel combustion) in Congo (Democratic)?
Provide a succinct answer. -19.3. In the year 1999, what is the difference between the CO2 emissions (% of total fuel combustion) of Middle income and CO2 emissions (% of total fuel combustion) of Finland?
Ensure brevity in your answer.  -6.68. In the year 1999, what is the difference between the CO2 emissions (% of total fuel combustion) of Middle income and CO2 emissions (% of total fuel combustion) of Sweden?
Give a very brief answer. -22.42. In the year 1999, what is the difference between the CO2 emissions (% of total fuel combustion) of Congo (Democratic) and CO2 emissions (% of total fuel combustion) of Finland?
Your response must be concise. 12.62. In the year 1999, what is the difference between the CO2 emissions (% of total fuel combustion) in Congo (Democratic) and CO2 emissions (% of total fuel combustion) in Sweden?
Keep it short and to the point. -3.12. In the year 1999, what is the difference between the CO2 emissions (% of total fuel combustion) in Finland and CO2 emissions (% of total fuel combustion) in Sweden?
Provide a short and direct response. -15.73. In the year 2000, what is the difference between the CO2 emissions (% of total fuel combustion) in Middle income and CO2 emissions (% of total fuel combustion) in Congo (Democratic)?
Your response must be concise. -76.29. In the year 2000, what is the difference between the CO2 emissions (% of total fuel combustion) in Middle income and CO2 emissions (% of total fuel combustion) in Finland?
Make the answer very short. -5.6. In the year 2000, what is the difference between the CO2 emissions (% of total fuel combustion) of Middle income and CO2 emissions (% of total fuel combustion) of Sweden?
Offer a very short reply. -24.88. In the year 2000, what is the difference between the CO2 emissions (% of total fuel combustion) in Congo (Democratic) and CO2 emissions (% of total fuel combustion) in Finland?
Provide a succinct answer. 70.69. In the year 2000, what is the difference between the CO2 emissions (% of total fuel combustion) of Congo (Democratic) and CO2 emissions (% of total fuel combustion) of Sweden?
Offer a terse response. 51.41. In the year 2000, what is the difference between the CO2 emissions (% of total fuel combustion) of Finland and CO2 emissions (% of total fuel combustion) of Sweden?
Provide a short and direct response. -19.27. In the year 2001, what is the difference between the CO2 emissions (% of total fuel combustion) in Middle income and CO2 emissions (% of total fuel combustion) in Congo (Democratic)?
Provide a short and direct response. -74.52. In the year 2001, what is the difference between the CO2 emissions (% of total fuel combustion) of Middle income and CO2 emissions (% of total fuel combustion) of Finland?
Your answer should be compact. -3.88. In the year 2001, what is the difference between the CO2 emissions (% of total fuel combustion) of Middle income and CO2 emissions (% of total fuel combustion) of Sweden?
Your answer should be very brief. -25.02. In the year 2001, what is the difference between the CO2 emissions (% of total fuel combustion) of Congo (Democratic) and CO2 emissions (% of total fuel combustion) of Finland?
Give a very brief answer. 70.64. In the year 2001, what is the difference between the CO2 emissions (% of total fuel combustion) of Congo (Democratic) and CO2 emissions (% of total fuel combustion) of Sweden?
Ensure brevity in your answer.  49.51. In the year 2001, what is the difference between the CO2 emissions (% of total fuel combustion) of Finland and CO2 emissions (% of total fuel combustion) of Sweden?
Your answer should be compact. -21.14. In the year 2002, what is the difference between the CO2 emissions (% of total fuel combustion) of Middle income and CO2 emissions (% of total fuel combustion) of Congo (Democratic)?
Your answer should be very brief. -74.06. In the year 2002, what is the difference between the CO2 emissions (% of total fuel combustion) of Middle income and CO2 emissions (% of total fuel combustion) of Finland?
Ensure brevity in your answer.  -3.43. In the year 2002, what is the difference between the CO2 emissions (% of total fuel combustion) of Middle income and CO2 emissions (% of total fuel combustion) of Sweden?
Make the answer very short. -24.17. In the year 2002, what is the difference between the CO2 emissions (% of total fuel combustion) in Congo (Democratic) and CO2 emissions (% of total fuel combustion) in Finland?
Keep it short and to the point. 70.63. In the year 2002, what is the difference between the CO2 emissions (% of total fuel combustion) of Congo (Democratic) and CO2 emissions (% of total fuel combustion) of Sweden?
Provide a short and direct response. 49.89. In the year 2002, what is the difference between the CO2 emissions (% of total fuel combustion) of Finland and CO2 emissions (% of total fuel combustion) of Sweden?
Offer a very short reply. -20.74. What is the ratio of the CO2 emissions (% of total fuel combustion) of Congo (Democratic) in 1996 to that in 1997?
Provide a succinct answer. 1.02. What is the ratio of the CO2 emissions (% of total fuel combustion) of Finland in 1996 to that in 1997?
Your answer should be compact. 0.91. What is the ratio of the CO2 emissions (% of total fuel combustion) of Sweden in 1996 to that in 1997?
Offer a very short reply. 0.89. What is the ratio of the CO2 emissions (% of total fuel combustion) in Middle income in 1996 to that in 1998?
Your response must be concise. 1.01. What is the ratio of the CO2 emissions (% of total fuel combustion) in Congo (Democratic) in 1996 to that in 1998?
Your answer should be very brief. 1.1. What is the ratio of the CO2 emissions (% of total fuel combustion) of Finland in 1996 to that in 1998?
Your answer should be compact. 0.85. What is the ratio of the CO2 emissions (% of total fuel combustion) of Sweden in 1996 to that in 1998?
Make the answer very short. 0.89. What is the ratio of the CO2 emissions (% of total fuel combustion) of Middle income in 1996 to that in 1999?
Provide a succinct answer. 0.98. What is the ratio of the CO2 emissions (% of total fuel combustion) in Congo (Democratic) in 1996 to that in 1999?
Offer a terse response. 1.15. What is the ratio of the CO2 emissions (% of total fuel combustion) of Finland in 1996 to that in 1999?
Your answer should be compact. 0.82. What is the ratio of the CO2 emissions (% of total fuel combustion) of Sweden in 1996 to that in 1999?
Your answer should be compact. 0.85. What is the ratio of the CO2 emissions (% of total fuel combustion) of Middle income in 1996 to that in 2000?
Your answer should be very brief. 0.94. What is the ratio of the CO2 emissions (% of total fuel combustion) of Congo (Democratic) in 1996 to that in 2000?
Ensure brevity in your answer.  0.43. What is the ratio of the CO2 emissions (% of total fuel combustion) of Finland in 1996 to that in 2000?
Provide a short and direct response. 0.84. What is the ratio of the CO2 emissions (% of total fuel combustion) of Sweden in 1996 to that in 2000?
Provide a short and direct response. 0.79. What is the ratio of the CO2 emissions (% of total fuel combustion) of Middle income in 1996 to that in 2001?
Offer a very short reply. 0.93. What is the ratio of the CO2 emissions (% of total fuel combustion) of Congo (Democratic) in 1996 to that in 2001?
Ensure brevity in your answer.  0.43. What is the ratio of the CO2 emissions (% of total fuel combustion) of Finland in 1996 to that in 2001?
Provide a succinct answer. 0.91. What is the ratio of the CO2 emissions (% of total fuel combustion) in Sweden in 1996 to that in 2001?
Your answer should be very brief. 0.78. What is the ratio of the CO2 emissions (% of total fuel combustion) of Middle income in 1996 to that in 2002?
Offer a very short reply. 0.93. What is the ratio of the CO2 emissions (% of total fuel combustion) of Congo (Democratic) in 1996 to that in 2002?
Your answer should be compact. 0.44. What is the ratio of the CO2 emissions (% of total fuel combustion) of Finland in 1996 to that in 2002?
Your answer should be very brief. 0.93. What is the ratio of the CO2 emissions (% of total fuel combustion) of Sweden in 1996 to that in 2002?
Ensure brevity in your answer.  0.8. What is the ratio of the CO2 emissions (% of total fuel combustion) in Middle income in 1997 to that in 1998?
Make the answer very short. 1.01. What is the ratio of the CO2 emissions (% of total fuel combustion) of Congo (Democratic) in 1997 to that in 1998?
Your response must be concise. 1.08. What is the ratio of the CO2 emissions (% of total fuel combustion) of Finland in 1997 to that in 1998?
Make the answer very short. 0.93. What is the ratio of the CO2 emissions (% of total fuel combustion) in Sweden in 1997 to that in 1998?
Ensure brevity in your answer.  1. What is the ratio of the CO2 emissions (% of total fuel combustion) of Middle income in 1997 to that in 1999?
Your answer should be compact. 0.98. What is the ratio of the CO2 emissions (% of total fuel combustion) of Congo (Democratic) in 1997 to that in 1999?
Your answer should be compact. 1.12. What is the ratio of the CO2 emissions (% of total fuel combustion) in Finland in 1997 to that in 1999?
Offer a terse response. 0.9. What is the ratio of the CO2 emissions (% of total fuel combustion) in Sweden in 1997 to that in 1999?
Provide a short and direct response. 0.95. What is the ratio of the CO2 emissions (% of total fuel combustion) of Middle income in 1997 to that in 2000?
Offer a very short reply. 0.94. What is the ratio of the CO2 emissions (% of total fuel combustion) of Congo (Democratic) in 1997 to that in 2000?
Give a very brief answer. 0.42. What is the ratio of the CO2 emissions (% of total fuel combustion) of Finland in 1997 to that in 2000?
Offer a very short reply. 0.92. What is the ratio of the CO2 emissions (% of total fuel combustion) in Sweden in 1997 to that in 2000?
Offer a very short reply. 0.88. What is the ratio of the CO2 emissions (% of total fuel combustion) in Middle income in 1997 to that in 2001?
Provide a short and direct response. 0.93. What is the ratio of the CO2 emissions (% of total fuel combustion) of Congo (Democratic) in 1997 to that in 2001?
Keep it short and to the point. 0.42. What is the ratio of the CO2 emissions (% of total fuel combustion) in Finland in 1997 to that in 2001?
Ensure brevity in your answer.  0.99. What is the ratio of the CO2 emissions (% of total fuel combustion) in Sweden in 1997 to that in 2001?
Give a very brief answer. 0.88. What is the ratio of the CO2 emissions (% of total fuel combustion) in Middle income in 1997 to that in 2002?
Make the answer very short. 0.93. What is the ratio of the CO2 emissions (% of total fuel combustion) in Congo (Democratic) in 1997 to that in 2002?
Your answer should be compact. 0.43. What is the ratio of the CO2 emissions (% of total fuel combustion) in Finland in 1997 to that in 2002?
Ensure brevity in your answer.  1.02. What is the ratio of the CO2 emissions (% of total fuel combustion) in Sweden in 1997 to that in 2002?
Make the answer very short. 0.9. What is the ratio of the CO2 emissions (% of total fuel combustion) of Middle income in 1998 to that in 1999?
Your answer should be compact. 0.97. What is the ratio of the CO2 emissions (% of total fuel combustion) in Congo (Democratic) in 1998 to that in 1999?
Your answer should be very brief. 1.04. What is the ratio of the CO2 emissions (% of total fuel combustion) of Finland in 1998 to that in 1999?
Keep it short and to the point. 0.96. What is the ratio of the CO2 emissions (% of total fuel combustion) of Sweden in 1998 to that in 1999?
Give a very brief answer. 0.96. What is the ratio of the CO2 emissions (% of total fuel combustion) of Middle income in 1998 to that in 2000?
Offer a terse response. 0.93. What is the ratio of the CO2 emissions (% of total fuel combustion) of Congo (Democratic) in 1998 to that in 2000?
Offer a very short reply. 0.39. What is the ratio of the CO2 emissions (% of total fuel combustion) in Finland in 1998 to that in 2000?
Your answer should be compact. 0.98. What is the ratio of the CO2 emissions (% of total fuel combustion) of Sweden in 1998 to that in 2000?
Your answer should be compact. 0.88. What is the ratio of the CO2 emissions (% of total fuel combustion) of Middle income in 1998 to that in 2001?
Provide a short and direct response. 0.92. What is the ratio of the CO2 emissions (% of total fuel combustion) of Congo (Democratic) in 1998 to that in 2001?
Provide a short and direct response. 0.39. What is the ratio of the CO2 emissions (% of total fuel combustion) in Finland in 1998 to that in 2001?
Offer a very short reply. 1.06. What is the ratio of the CO2 emissions (% of total fuel combustion) of Sweden in 1998 to that in 2001?
Make the answer very short. 0.88. What is the ratio of the CO2 emissions (% of total fuel combustion) of Middle income in 1998 to that in 2002?
Provide a succinct answer. 0.92. What is the ratio of the CO2 emissions (% of total fuel combustion) in Congo (Democratic) in 1998 to that in 2002?
Your answer should be compact. 0.4. What is the ratio of the CO2 emissions (% of total fuel combustion) in Finland in 1998 to that in 2002?
Provide a succinct answer. 1.09. What is the ratio of the CO2 emissions (% of total fuel combustion) of Sweden in 1998 to that in 2002?
Your answer should be compact. 0.9. What is the ratio of the CO2 emissions (% of total fuel combustion) of Middle income in 1999 to that in 2000?
Your response must be concise. 0.96. What is the ratio of the CO2 emissions (% of total fuel combustion) of Congo (Democratic) in 1999 to that in 2000?
Your answer should be very brief. 0.37. What is the ratio of the CO2 emissions (% of total fuel combustion) in Finland in 1999 to that in 2000?
Provide a short and direct response. 1.02. What is the ratio of the CO2 emissions (% of total fuel combustion) in Sweden in 1999 to that in 2000?
Provide a succinct answer. 0.92. What is the ratio of the CO2 emissions (% of total fuel combustion) in Middle income in 1999 to that in 2001?
Offer a terse response. 0.95. What is the ratio of the CO2 emissions (% of total fuel combustion) of Congo (Democratic) in 1999 to that in 2001?
Offer a very short reply. 0.38. What is the ratio of the CO2 emissions (% of total fuel combustion) in Finland in 1999 to that in 2001?
Your answer should be very brief. 1.1. What is the ratio of the CO2 emissions (% of total fuel combustion) in Sweden in 1999 to that in 2001?
Your answer should be very brief. 0.92. What is the ratio of the CO2 emissions (% of total fuel combustion) of Middle income in 1999 to that in 2002?
Ensure brevity in your answer.  0.95. What is the ratio of the CO2 emissions (% of total fuel combustion) of Congo (Democratic) in 1999 to that in 2002?
Offer a terse response. 0.38. What is the ratio of the CO2 emissions (% of total fuel combustion) in Finland in 1999 to that in 2002?
Your answer should be very brief. 1.13. What is the ratio of the CO2 emissions (% of total fuel combustion) in Sweden in 1999 to that in 2002?
Your answer should be very brief. 0.94. What is the ratio of the CO2 emissions (% of total fuel combustion) of Middle income in 2000 to that in 2001?
Your answer should be very brief. 0.99. What is the ratio of the CO2 emissions (% of total fuel combustion) in Congo (Democratic) in 2000 to that in 2001?
Make the answer very short. 1.02. What is the ratio of the CO2 emissions (% of total fuel combustion) of Finland in 2000 to that in 2001?
Offer a very short reply. 1.08. What is the ratio of the CO2 emissions (% of total fuel combustion) of Sweden in 2000 to that in 2001?
Give a very brief answer. 0.99. What is the ratio of the CO2 emissions (% of total fuel combustion) in Congo (Democratic) in 2000 to that in 2002?
Offer a very short reply. 1.02. What is the ratio of the CO2 emissions (% of total fuel combustion) of Finland in 2000 to that in 2002?
Make the answer very short. 1.11. What is the ratio of the CO2 emissions (% of total fuel combustion) of Sweden in 2000 to that in 2002?
Offer a very short reply. 1.02. What is the ratio of the CO2 emissions (% of total fuel combustion) of Congo (Democratic) in 2001 to that in 2002?
Offer a very short reply. 1.01. What is the ratio of the CO2 emissions (% of total fuel combustion) of Finland in 2001 to that in 2002?
Give a very brief answer. 1.03. What is the difference between the highest and the second highest CO2 emissions (% of total fuel combustion) in Middle income?
Provide a succinct answer. 0.07. What is the difference between the highest and the second highest CO2 emissions (% of total fuel combustion) in Congo (Democratic)?
Offer a terse response. 1.62. What is the difference between the highest and the second highest CO2 emissions (% of total fuel combustion) of Finland?
Provide a short and direct response. 0.43. What is the difference between the highest and the second highest CO2 emissions (% of total fuel combustion) in Sweden?
Offer a very short reply. 0.28. What is the difference between the highest and the lowest CO2 emissions (% of total fuel combustion) of Middle income?
Provide a short and direct response. 1.24. What is the difference between the highest and the lowest CO2 emissions (% of total fuel combustion) in Congo (Democratic)?
Your answer should be very brief. 57.64. What is the difference between the highest and the lowest CO2 emissions (% of total fuel combustion) of Finland?
Your answer should be compact. 3.86. What is the difference between the highest and the lowest CO2 emissions (% of total fuel combustion) in Sweden?
Keep it short and to the point. 8.91. 